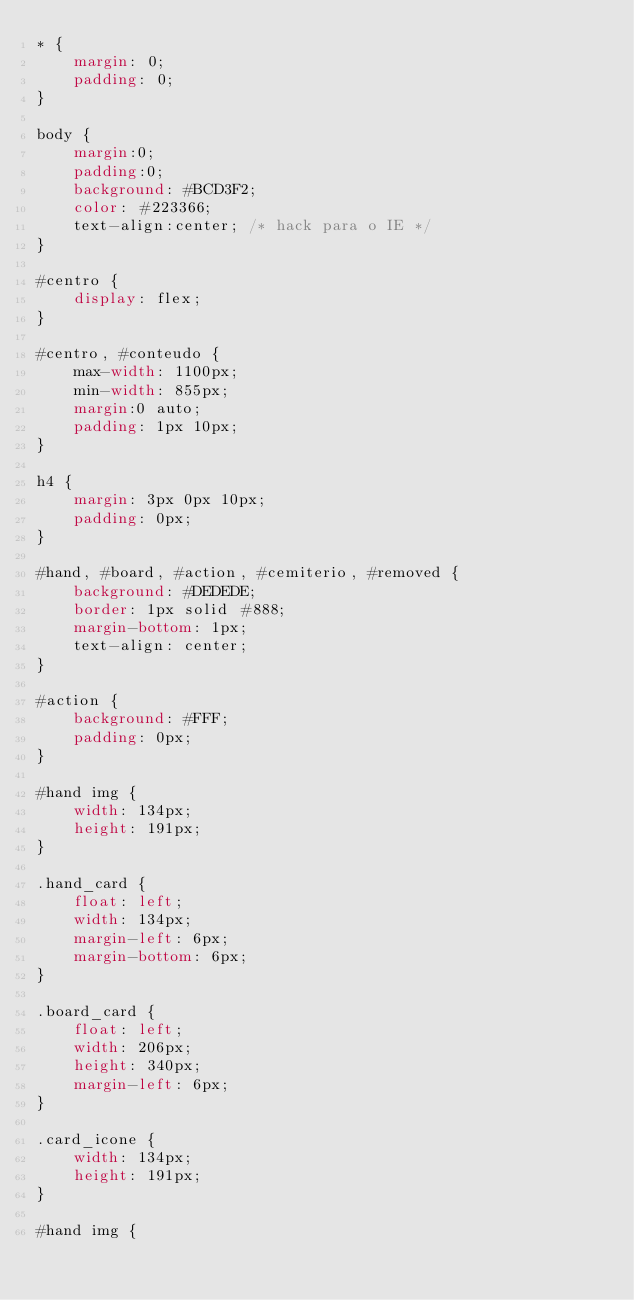Convert code to text. <code><loc_0><loc_0><loc_500><loc_500><_CSS_>* {
    margin: 0;
    padding: 0;
}

body {
    margin:0;
    padding:0;
    background: #BCD3F2;
    color: #223366;
    text-align:center; /* hack para o IE */	
}

#centro {
    display: flex;
}

#centro, #conteudo {
    max-width: 1100px;
    min-width: 855px;
    margin:0 auto;			
    padding: 1px 10px;
}

h4 {
    margin: 3px 0px 10px;
    padding: 0px;
}

#hand, #board, #action, #cemiterio, #removed {
    background: #DEDEDE;
    border: 1px solid #888;
    margin-bottom: 1px;
    text-align: center;
}

#action {
    background: #FFF;
    padding: 0px;
}

#hand img {
    width: 134px;
    height: 191px;
}

.hand_card {
    float: left;
    width: 134px;
    margin-left: 6px;
    margin-bottom: 6px;
}

.board_card {
    float: left;
    width: 206px;
    height: 340px;
    margin-left: 6px;
}

.card_icone {
    width: 134px;
    height: 191px;
}

#hand img {</code> 